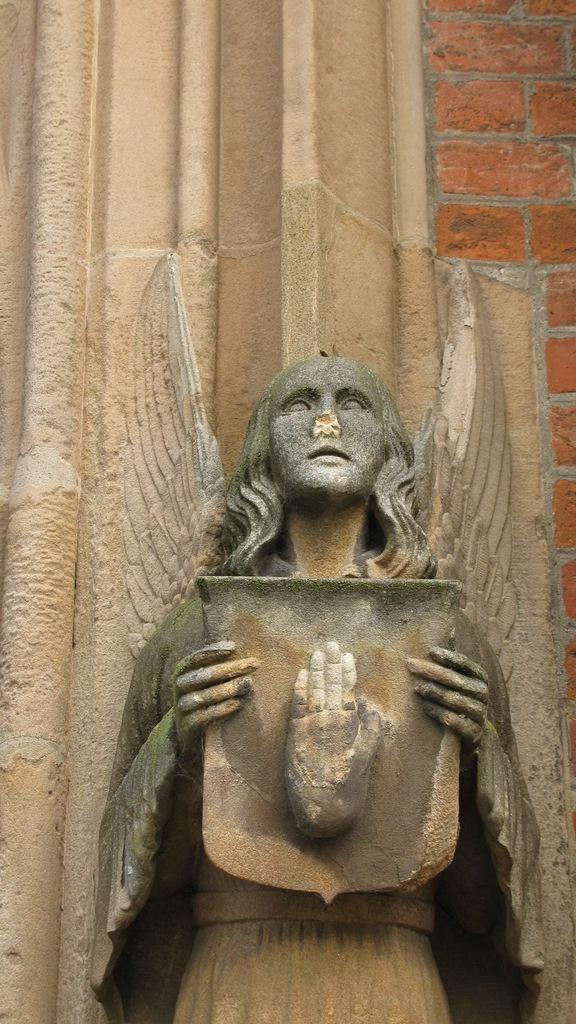Please provide a concise description of this image. In this image I can see the statue in brown and grey color. Background the wall is in cream and brown color. 